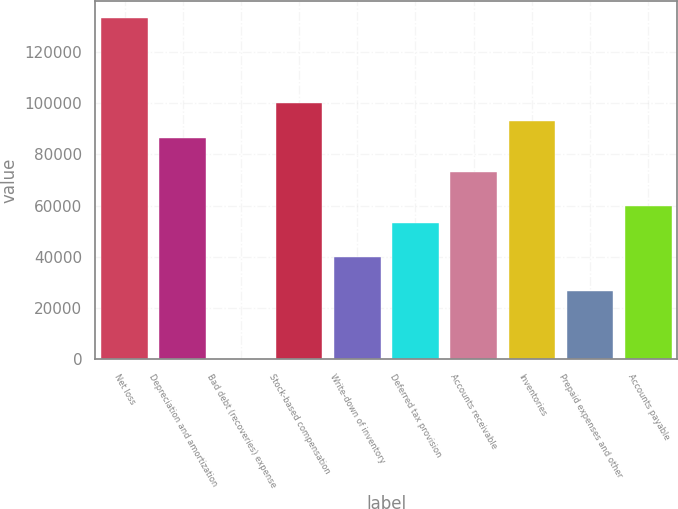<chart> <loc_0><loc_0><loc_500><loc_500><bar_chart><fcel>Net loss<fcel>Depreciation and amortization<fcel>Bad debt (recoveries) expense<fcel>Stock-based compensation<fcel>Write-down of inventory<fcel>Deferred tax provision<fcel>Accounts receivable<fcel>Inventories<fcel>Prepaid expenses and other<fcel>Accounts payable<nl><fcel>133107<fcel>86522<fcel>7<fcel>99832<fcel>39937<fcel>53247<fcel>73212<fcel>93177<fcel>26627<fcel>59902<nl></chart> 